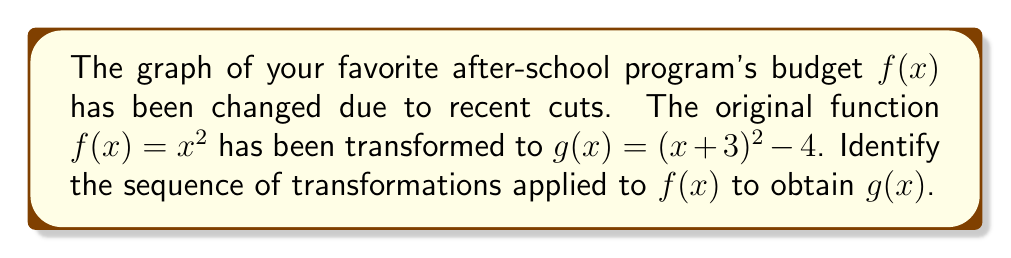Give your solution to this math problem. Let's approach this step-by-step:

1) The general form of a quadratic function is $f(x)=a(x-h)^2+k$, where:
   - $a$ affects the vertical stretch/compression
   - $h$ affects the horizontal shift
   - $k$ affects the vertical shift

2) Our original function is $f(x)=x^2$

3) Our transformed function is $g(x)=(x+3)^2-4$

4) Comparing $g(x)$ to the general form:
   - $a=1$ (no vertical stretch/compression)
   - Inside the parentheses, we have $(x+3)$ instead of $(x-h)$, so $h=-3$
   - Outside the parentheses, we have $-4$, so $k=-4$

5) Interpreting these values:
   - $h=-3$ means a horizontal shift 3 units to the left
   - $k=-4$ means a vertical shift 4 units down

6) The order of transformations matters. For compound transformations, we apply horizontal shifts before vertical shifts.

Therefore, the sequence of transformations is:
1. Shift 3 units to the left
2. Shift 4 units down
Answer: Shift 3 units left, then 4 units down 